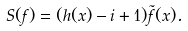<formula> <loc_0><loc_0><loc_500><loc_500>S ( f ) = ( h ( x ) - i + 1 ) \tilde { f } ( x ) .</formula> 